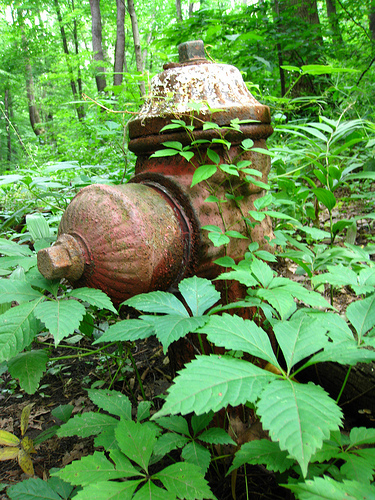What details in the image stand out the most? The most striking detail in the image is the contrast between the rusty, aged fire hydrant and the lush, vibrant green vegetation surrounding it. The hydrant's weathered texture and earthy tones juxtapose the fresh, lively foliage, creating a captivating scene. If you could give the fire hydrant a name, what would it be and why? I would name it 'Guardian of the Forest.' This name reflects its past role as a protector against fires and its current state as a sentinel standing amidst the greenery, watching over the forest in silence. Imagine a fantasy world where the hydrant is a sentient being. Describe its thoughts and feelings. In a fantastical world, the fire hydrant, 'Guardian of the Forest,' possesses a heart of iron and a soul intertwined with nature. It remembers the days of its youth when it stood proudly, a bastion against the flames. Now, as it rusts and its colors fade, it feels a profound connection to the encroaching forest. It mourns its past purpose but finds solace in the beauty of the wilderness embracing it. Every drop of rain that gently kisses its surface feels like a reminder of its glory days, and every rustle of leaves is a comforting whisper, telling it that it still belongs. 